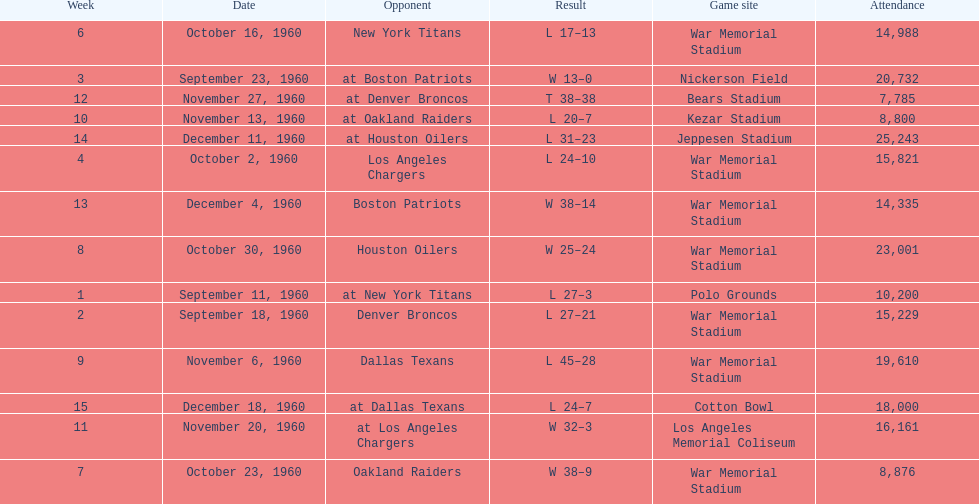What was the largest difference of points in a single game? 29. 